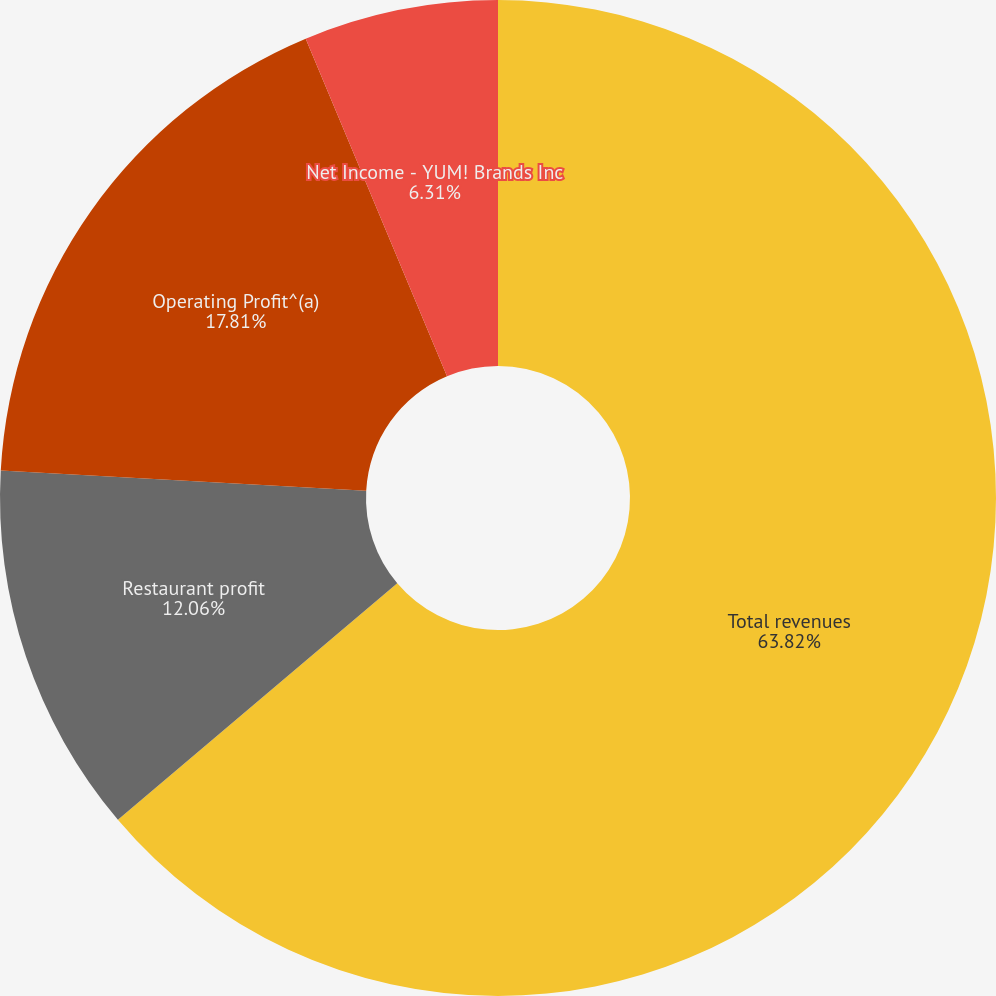Convert chart to OTSL. <chart><loc_0><loc_0><loc_500><loc_500><pie_chart><fcel>Total revenues<fcel>Restaurant profit<fcel>Operating Profit^(a)<fcel>Net Income - YUM! Brands Inc<nl><fcel>63.82%<fcel>12.06%<fcel>17.81%<fcel>6.31%<nl></chart> 